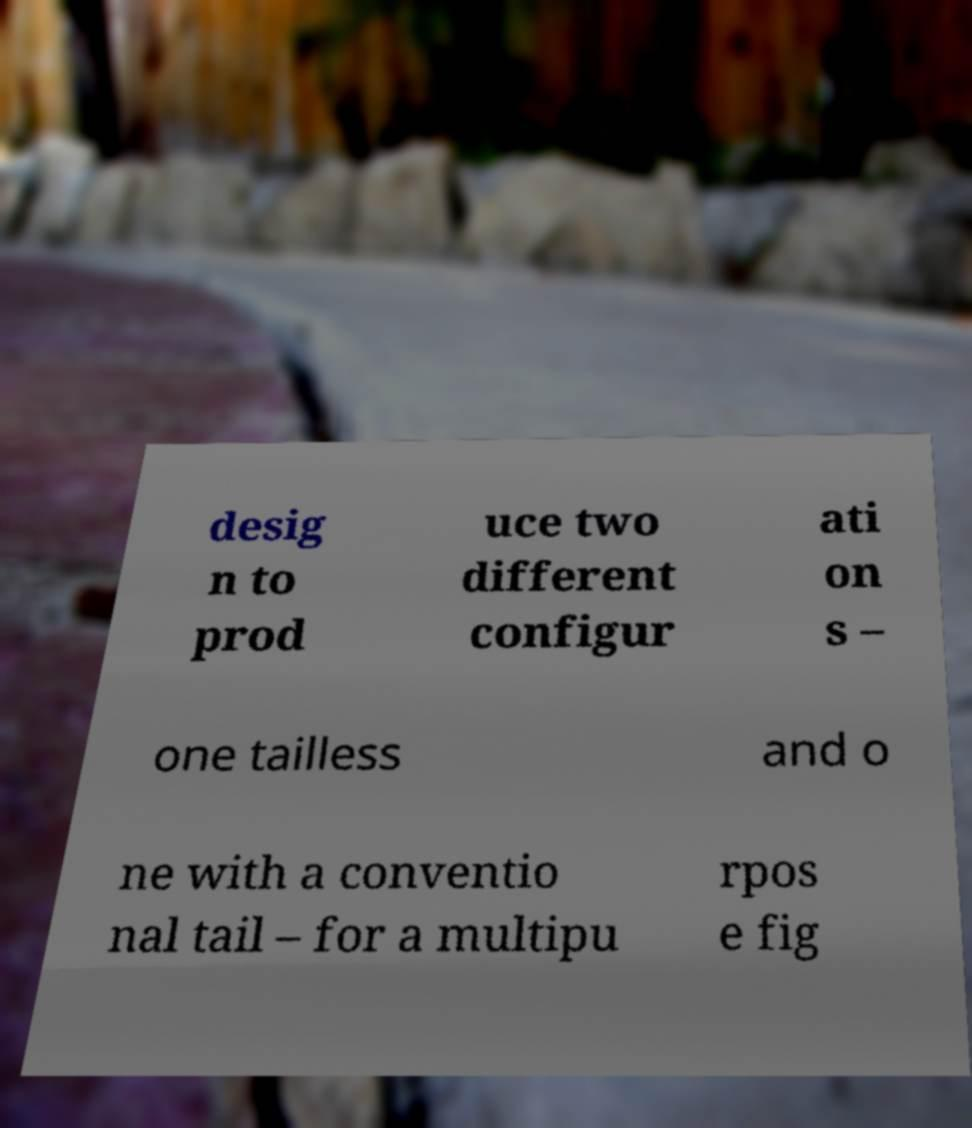Can you read and provide the text displayed in the image?This photo seems to have some interesting text. Can you extract and type it out for me? desig n to prod uce two different configur ati on s – one tailless and o ne with a conventio nal tail – for a multipu rpos e fig 